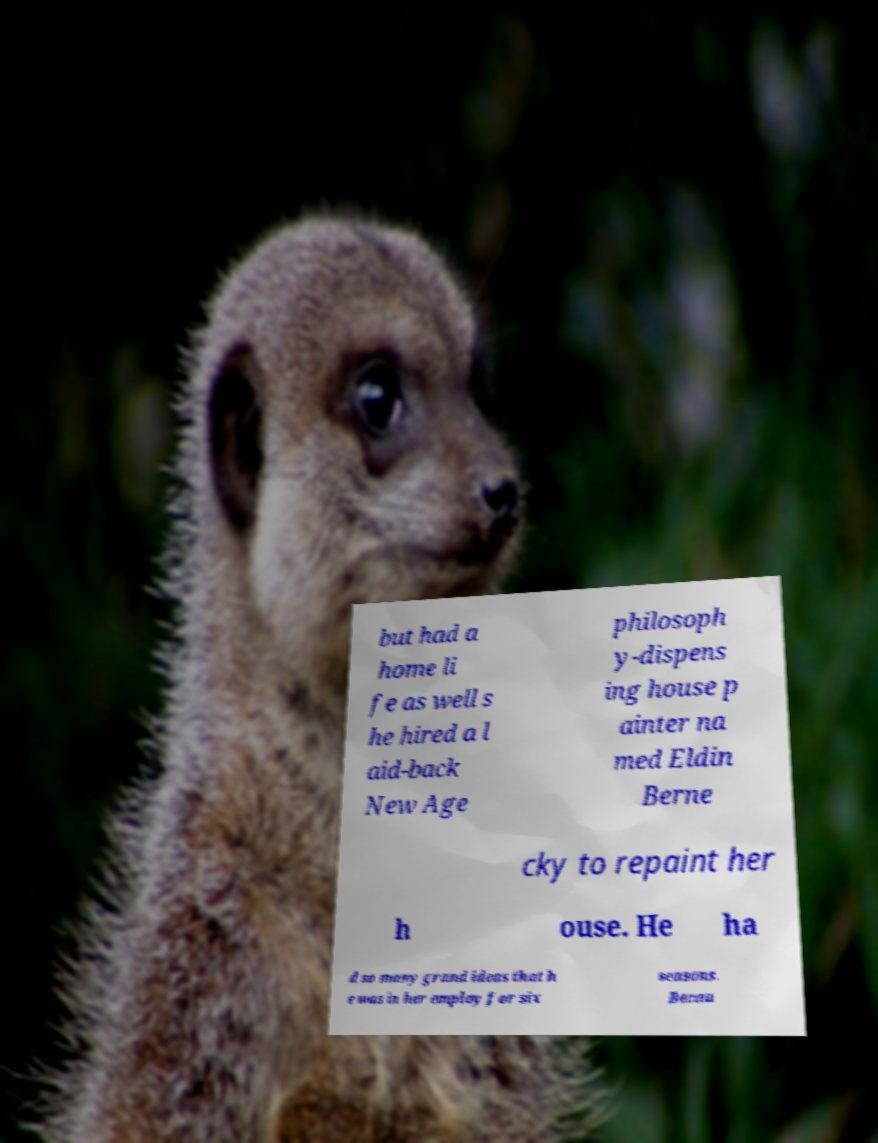Can you accurately transcribe the text from the provided image for me? but had a home li fe as well s he hired a l aid-back New Age philosoph y-dispens ing house p ainter na med Eldin Berne cky to repaint her h ouse. He ha d so many grand ideas that h e was in her employ for six seasons. Becau 